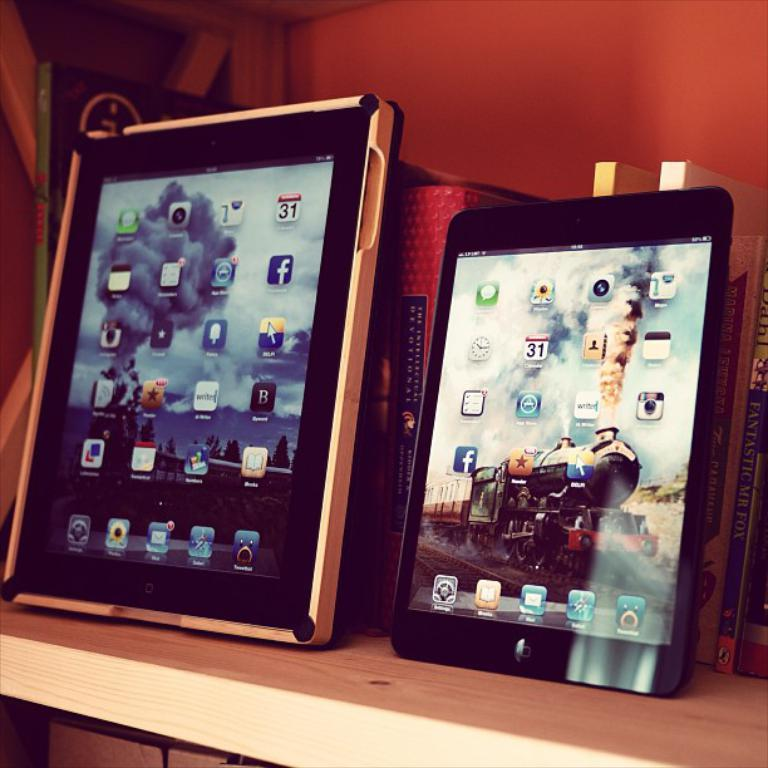What electronic devices are visible in the image? There are iPads in the image. What type of storage is used for the books in the image? The books are on a wooden rack in the image. What can be seen in the background of the image? The background of the image includes a wall. What is displayed on the iPad screens? The iPad screens display icons and images. How many men are visible in the image, and what are they wearing around their necks? There are no men visible in the image, and therefore we cannot determine what they might be wearing around their necks. 